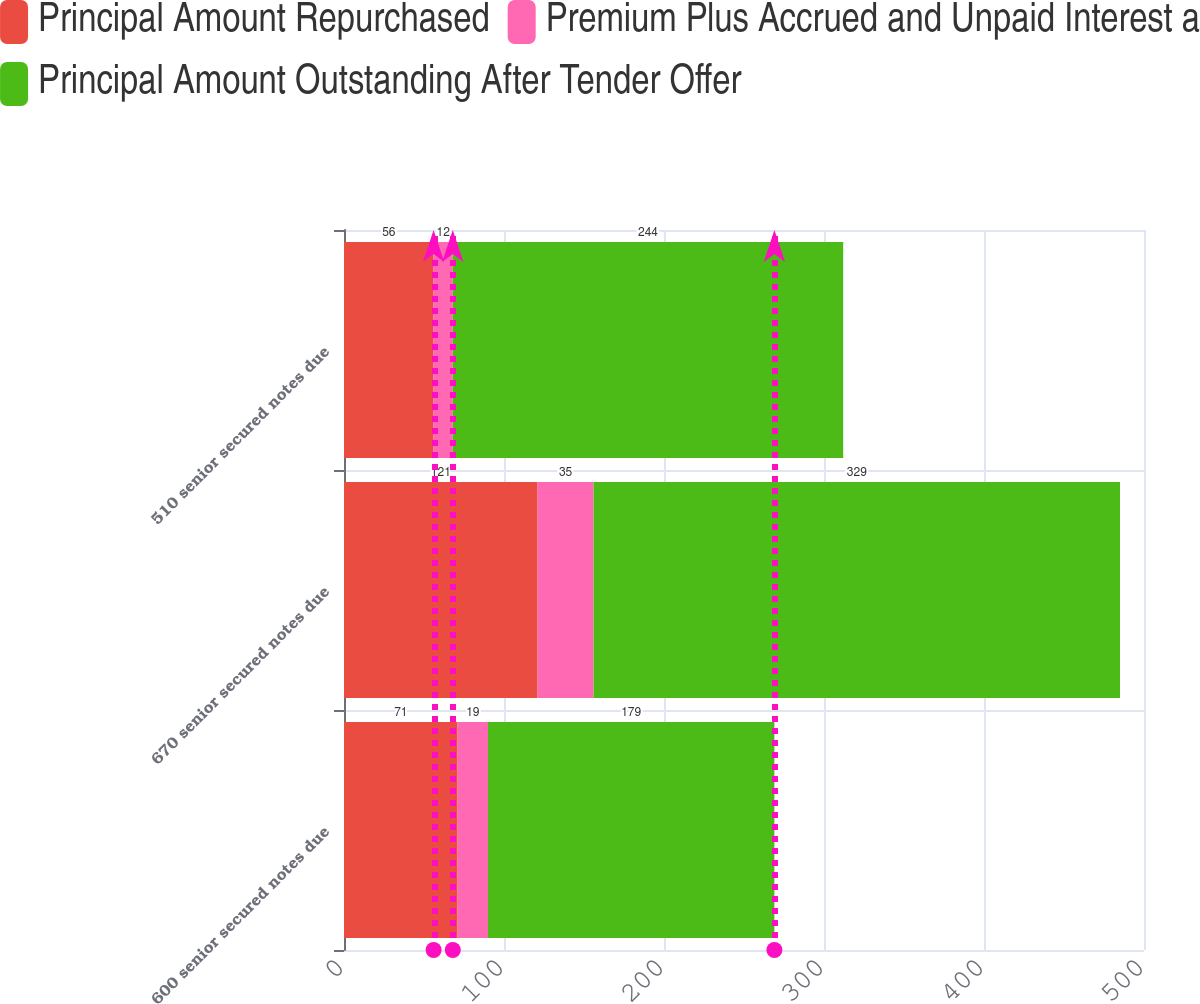Convert chart. <chart><loc_0><loc_0><loc_500><loc_500><stacked_bar_chart><ecel><fcel>600 senior secured notes due<fcel>670 senior secured notes due<fcel>510 senior secured notes due<nl><fcel>Principal Amount Repurchased<fcel>71<fcel>121<fcel>56<nl><fcel>Premium Plus Accrued and Unpaid Interest a<fcel>19<fcel>35<fcel>12<nl><fcel>Principal Amount Outstanding After Tender Offer<fcel>179<fcel>329<fcel>244<nl></chart> 